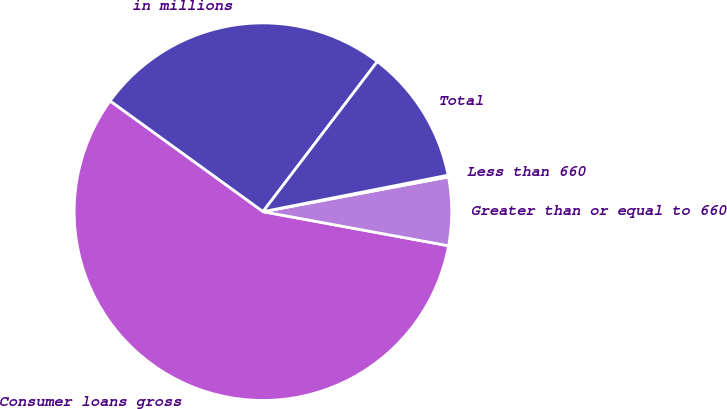Convert chart to OTSL. <chart><loc_0><loc_0><loc_500><loc_500><pie_chart><fcel>in millions<fcel>Consumer loans gross<fcel>Greater than or equal to 660<fcel>Less than 660<fcel>Total<nl><fcel>25.39%<fcel>57.08%<fcel>5.84%<fcel>0.15%<fcel>11.54%<nl></chart> 